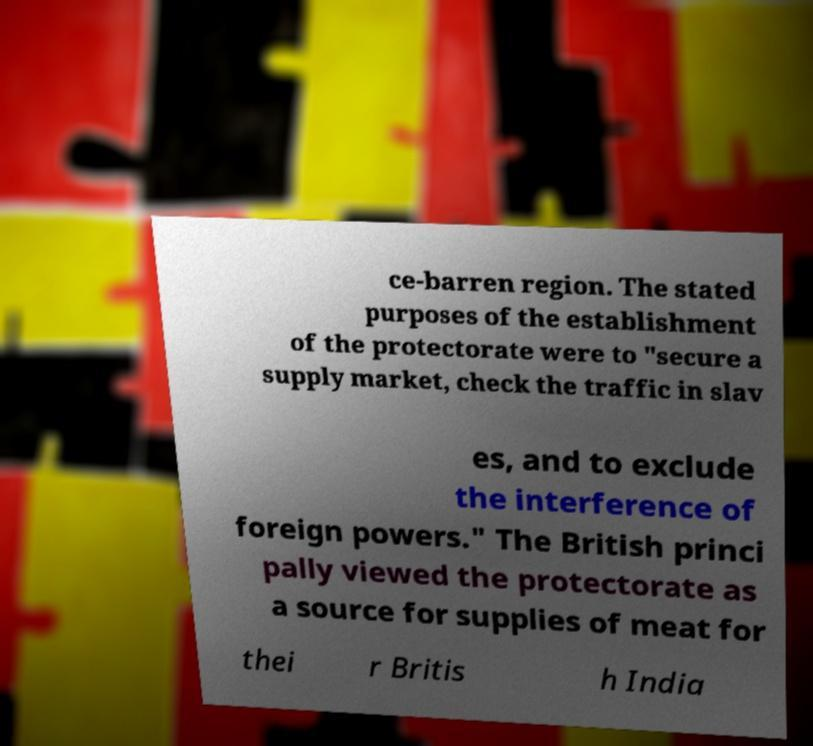What messages or text are displayed in this image? I need them in a readable, typed format. ce-barren region. The stated purposes of the establishment of the protectorate were to "secure a supply market, check the traffic in slav es, and to exclude the interference of foreign powers." The British princi pally viewed the protectorate as a source for supplies of meat for thei r Britis h India 